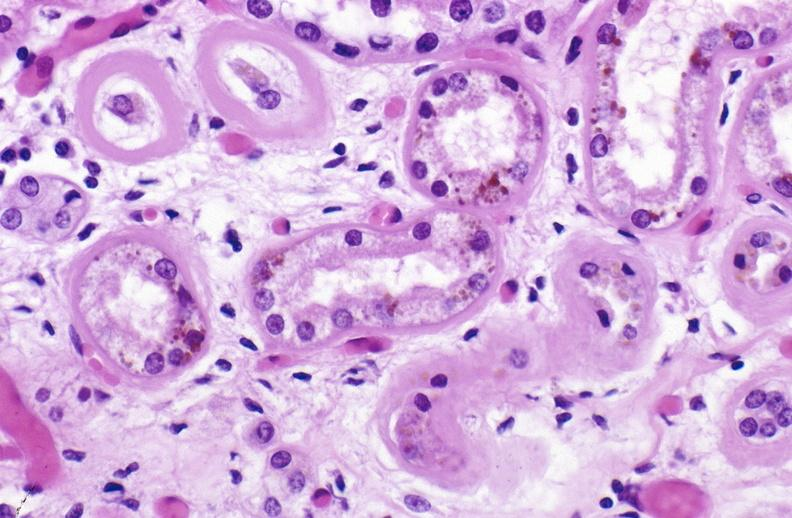s mucicarmine present?
Answer the question using a single word or phrase. No 